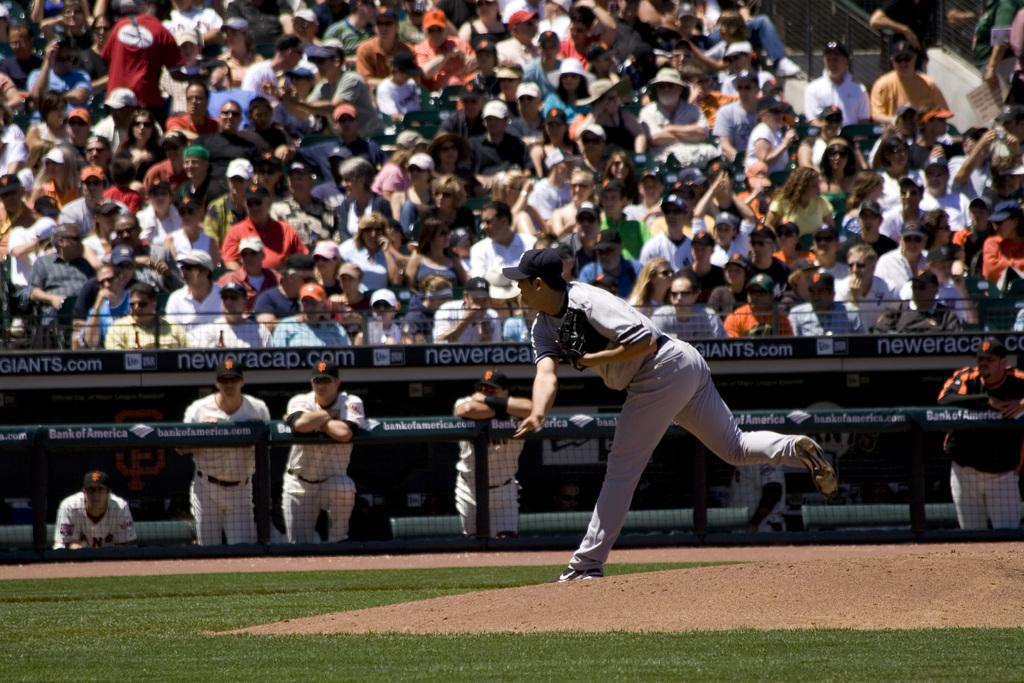What is the main subject of the image? The main subject of the image is a group of people. What are some of the people in the image doing? Some people are sitting, and some people are standing. What can be observed about the attire of some individuals in the image? Some people are wearing black gloves. What is the main theory discussed by the people in the image? There is no information about a theory being discussed in the image. What hobbies do the people in the image have? There is no information about the hobbies of the people in the image. 